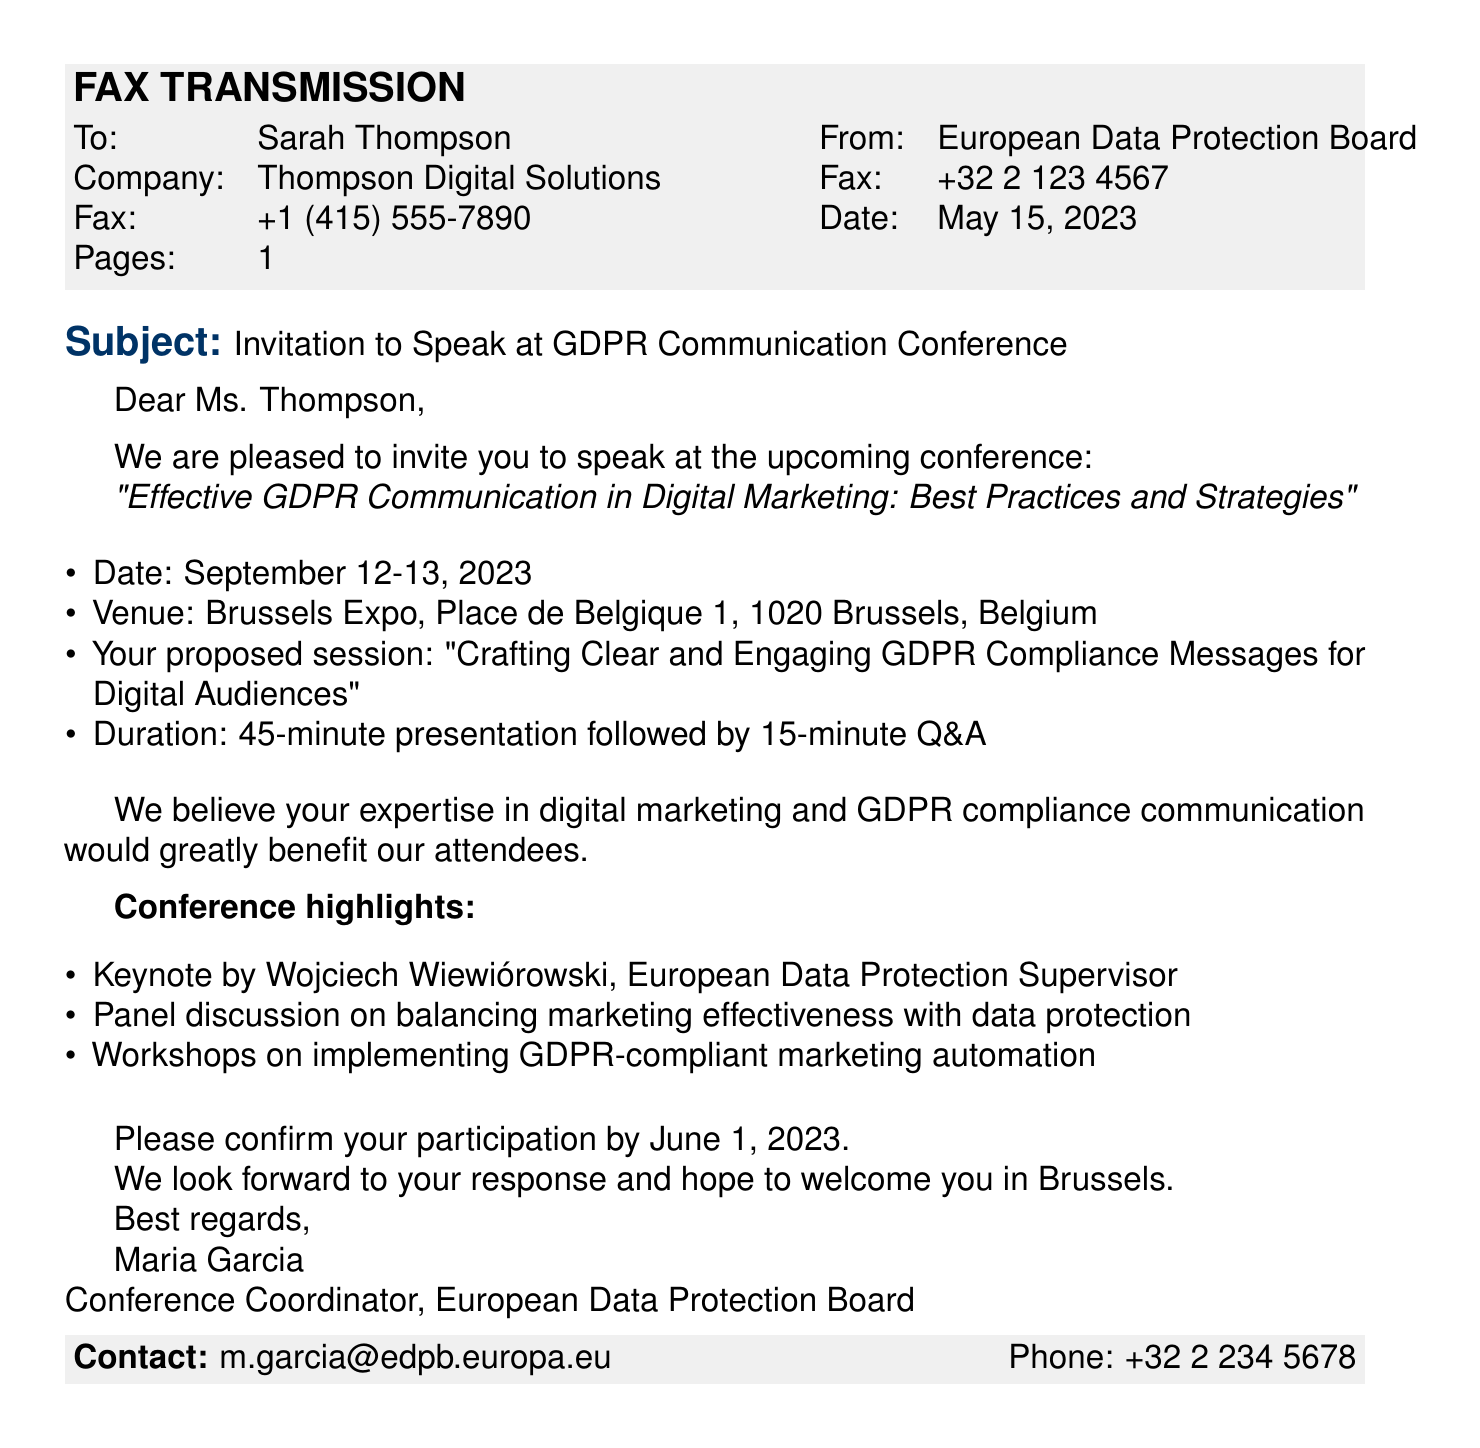What is the recipient's name? The recipient's name is explicitly mentioned in the salutation as Ms. Thompson.
Answer: Ms. Thompson What is the subject of the fax? The subject line clearly states the purpose of the fax as an invitation to speak at a conference.
Answer: Invitation to Speak at GDPR Communication Conference When is the conference scheduled? The document specifies the date of the conference as September 12-13, 2023.
Answer: September 12-13, 2023 Where is the conference venue located? The venue address is provided in the body of the fax, indicating the location of the conference.
Answer: Brussels Expo, Place de Belgique 1, 1020 Brussels, Belgium What is the duration of the proposed session? The document outlines the duration of the presentation and Q&A.
Answer: 45-minute presentation followed by 15-minute Q&A Who is the keynote speaker mentioned? A prominent figure mentioned is Wojciech Wiewiórowski, as per the conference highlights section.
Answer: Wojciech Wiewiórowski What is the deadline for confirmation of participation? The confirmation deadline is mentioned in the closing section of the document.
Answer: June 1, 2023 What role does Maria Garcia hold? The closing of the document indicates Maria Garcia's professional title related to the conference organization.
Answer: Conference Coordinator What is the method of communication provided for contact? The contact information includes an email address and a phone number for further communication.
Answer: m.garcia@edpb.europa.eu 